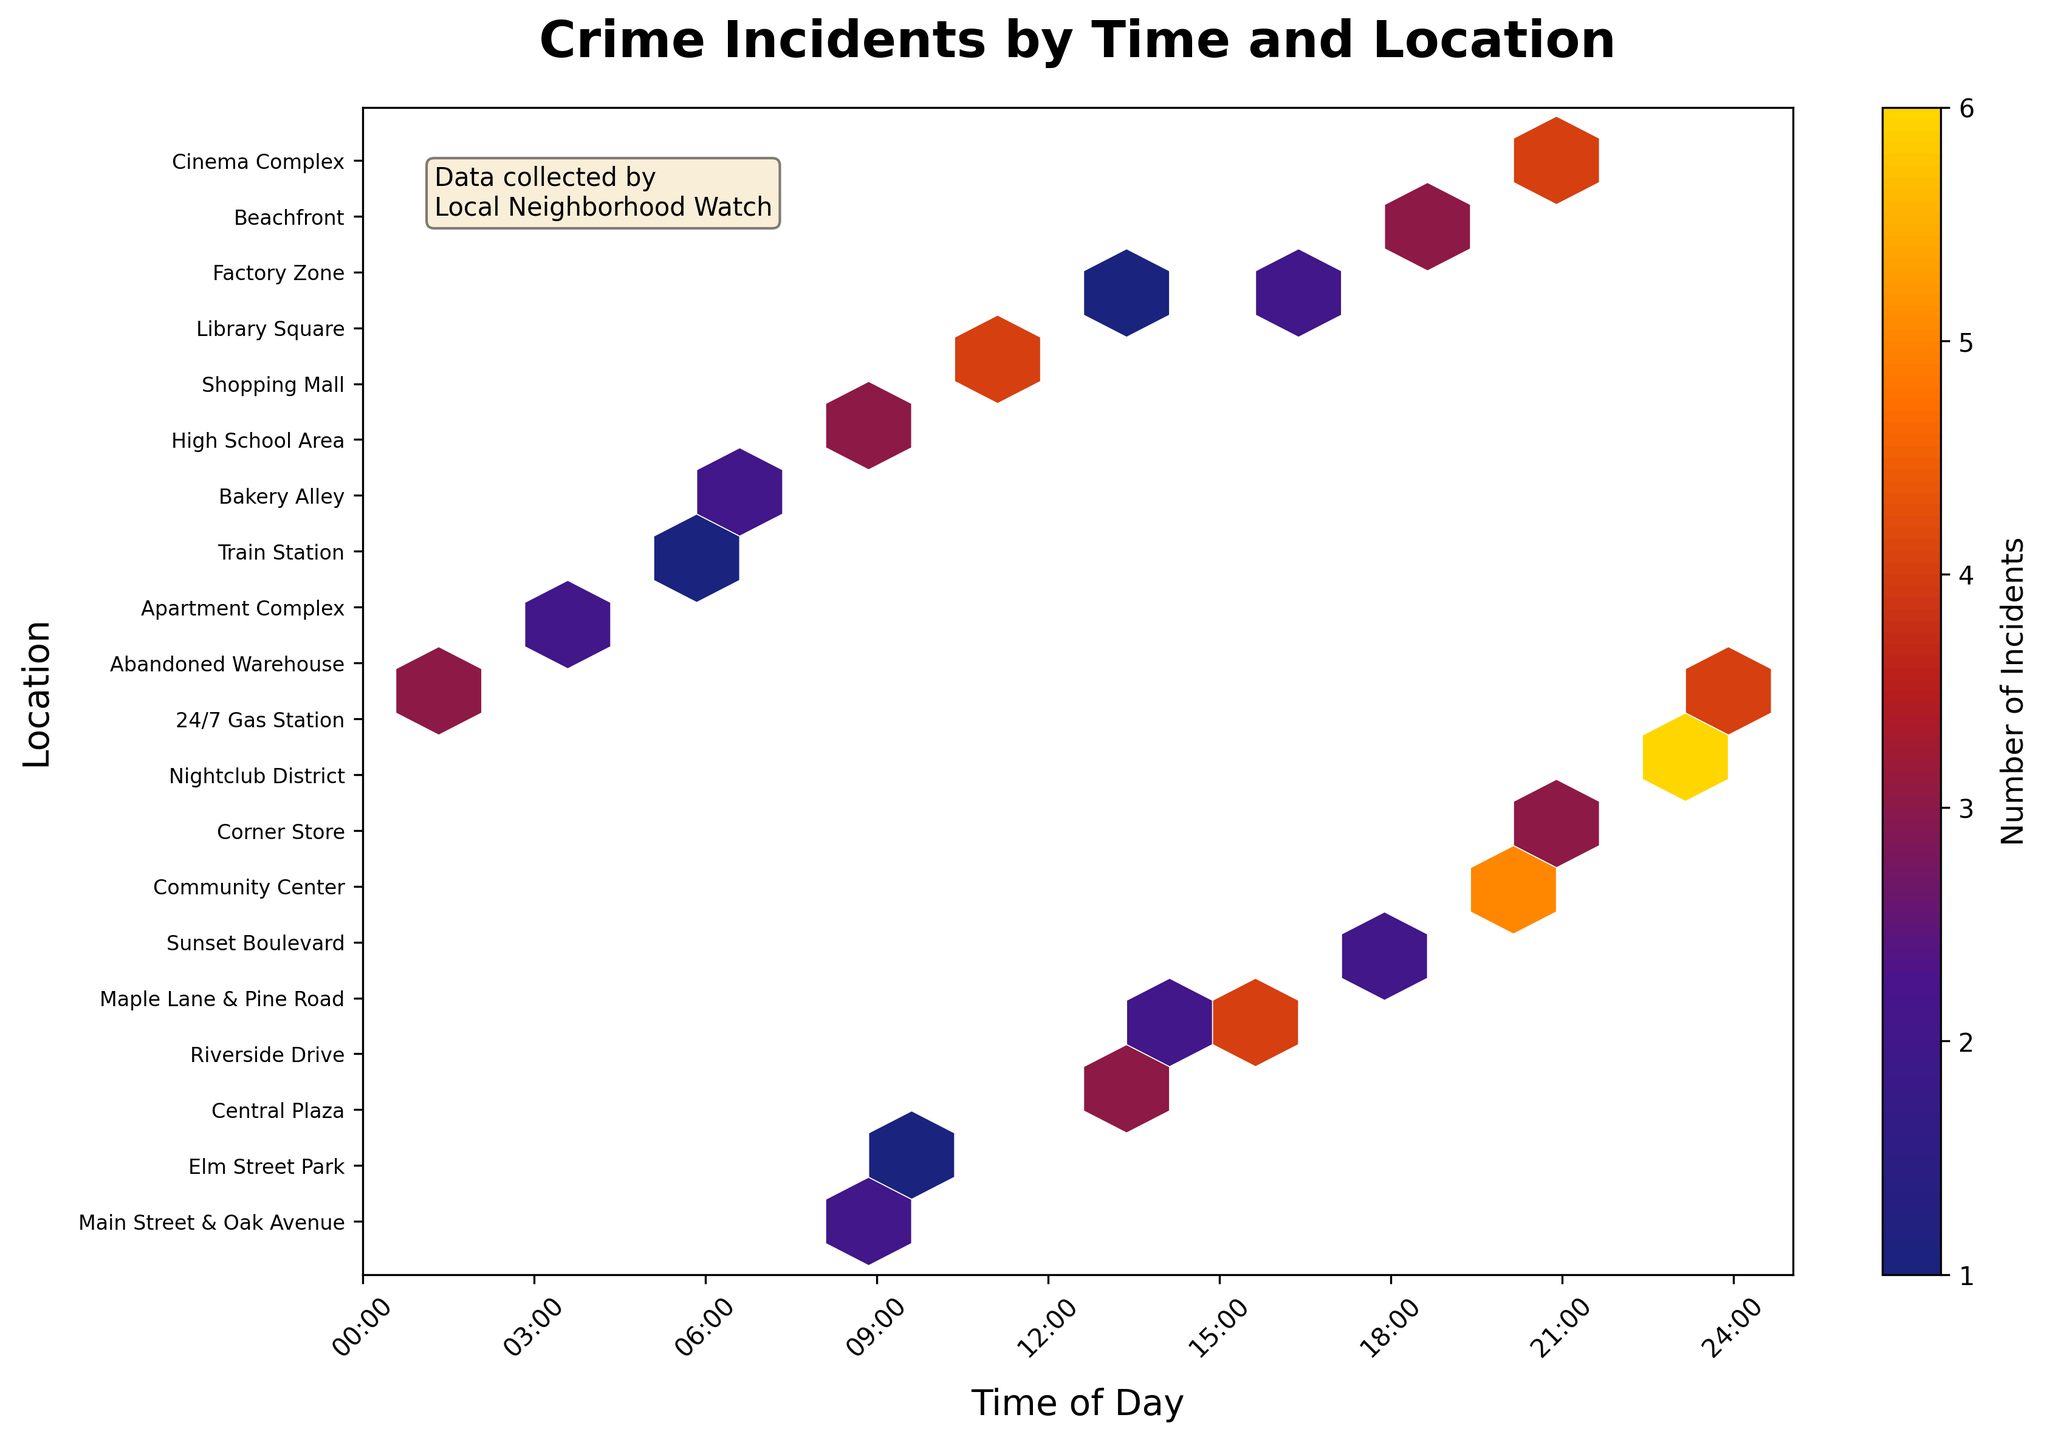what is the title of the plot? The plot has a title at the top which reads "Crime Incidents by Time and Location".
Answer: Crime Incidents by Time and Location which time period has the most crime incidents? To find the time period with the most crime incidents, look at the x-axis and identify the hexagons with the highest color intensity. The time period around 22:30 appears to have high intensity.
Answer: 22:30 how is the color intensity linked to crime incidents? The color intensity corresponds to the number of crime incidents, where darker colors indicate more incidents. This can be seen from the color legend on the side of the plot.
Answer: Darker colors indicate more incidents how many unique locations are shown in the plot? Each unique location is represented by a different tick mark on the y-axis. Counting these tick marks gives the total number of unique locations. There are 20 unique locations listed.
Answer: 20 between which two time periods do the most severe incidents appear to occur? Look for the densest and darkest hexagons on the x-axis. Comparing the intensities, between 19:00 and 23:00 has the highest concentration of severe incidents.
Answer: 19:00 and 23:00 which location has the most incidents at night? To determine this, observe the y-axis locations against the darker hexagons after 18:00 (evening hours). The Nightclub District stands out with a high density around 22:30.
Answer: Nightclub District during which time intervals are crimes at "High School Area" highest? Find the "High School Area" on the y-axis and then look at the hexagons along the x-axis corresponding to this line. The darkest hexagon appears around 09:00, indicating a high number of incidents then.
Answer: 09:00 which locations have crime incidents in the early morning (before 6 am)? Checking the first 6 hours on the x-axis, we observe incidents at the Apartment Complex, Abandoned Warehouse, 24/7 Gas Station, and Bakery Alley.
Answer: Apartment Complex, Abandoned Warehouse, 24/7 Gas Station, Bakery Alley what does the color bar indicate in this hexbin plot? The color bar is a legend that explains the number of incidents, with lighter colors representing fewer incidents and darker colors representing more incidents.
Answer: Number of incidents which locations are crime-free at any time of the day? Complete absence of hexagons along any line in the y-axis would indicate a crime-free location. All locations have some level of incidents as there are no empty y-axis lines.
Answer: None 